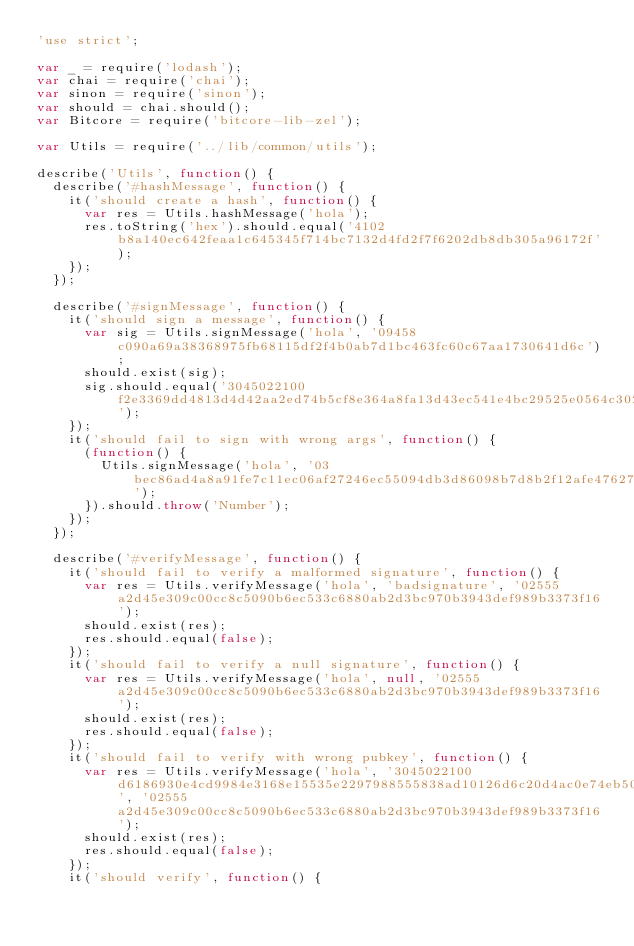<code> <loc_0><loc_0><loc_500><loc_500><_JavaScript_>'use strict';

var _ = require('lodash');
var chai = require('chai');
var sinon = require('sinon');
var should = chai.should();
var Bitcore = require('bitcore-lib-zel');

var Utils = require('../lib/common/utils');

describe('Utils', function() {
  describe('#hashMessage', function() {
    it('should create a hash', function() {
      var res = Utils.hashMessage('hola');
      res.toString('hex').should.equal('4102b8a140ec642feaa1c645345f714bc7132d4fd2f7f6202db8db305a96172f');
    });
  });

  describe('#signMessage', function() {
    it('should sign a message', function() {
      var sig = Utils.signMessage('hola', '09458c090a69a38368975fb68115df2f4b0ab7d1bc463fc60c67aa1730641d6c');
      should.exist(sig);
      sig.should.equal('3045022100f2e3369dd4813d4d42aa2ed74b5cf8e364a8fa13d43ec541e4bc29525e0564c302205b37a7d1ca73f684f91256806cdad4b320b4ed3000bee2e388bcec106e0280e0');
    });
    it('should fail to sign with wrong args', function() {
      (function() {
        Utils.signMessage('hola', '03bec86ad4a8a91fe7c11ec06af27246ec55094db3d86098b7d8b2f12afe47627f');
      }).should.throw('Number');
    });
  });

  describe('#verifyMessage', function() {
    it('should fail to verify a malformed signature', function() {
      var res = Utils.verifyMessage('hola', 'badsignature', '02555a2d45e309c00cc8c5090b6ec533c6880ab2d3bc970b3943def989b3373f16');
      should.exist(res);
      res.should.equal(false);
    });
    it('should fail to verify a null signature', function() {
      var res = Utils.verifyMessage('hola', null, '02555a2d45e309c00cc8c5090b6ec533c6880ab2d3bc970b3943def989b3373f16');
      should.exist(res);
      res.should.equal(false);
    });
    it('should fail to verify with wrong pubkey', function() {
      var res = Utils.verifyMessage('hola', '3045022100d6186930e4cd9984e3168e15535e2297988555838ad10126d6c20d4ac0e74eb502201095a6319ea0a0de1f1e5fb50f7bf10b8069de10e0083e23dbbf8de9b8e02785', '02555a2d45e309c00cc8c5090b6ec533c6880ab2d3bc970b3943def989b3373f16');
      should.exist(res);
      res.should.equal(false);
    });
    it('should verify', function() {</code> 